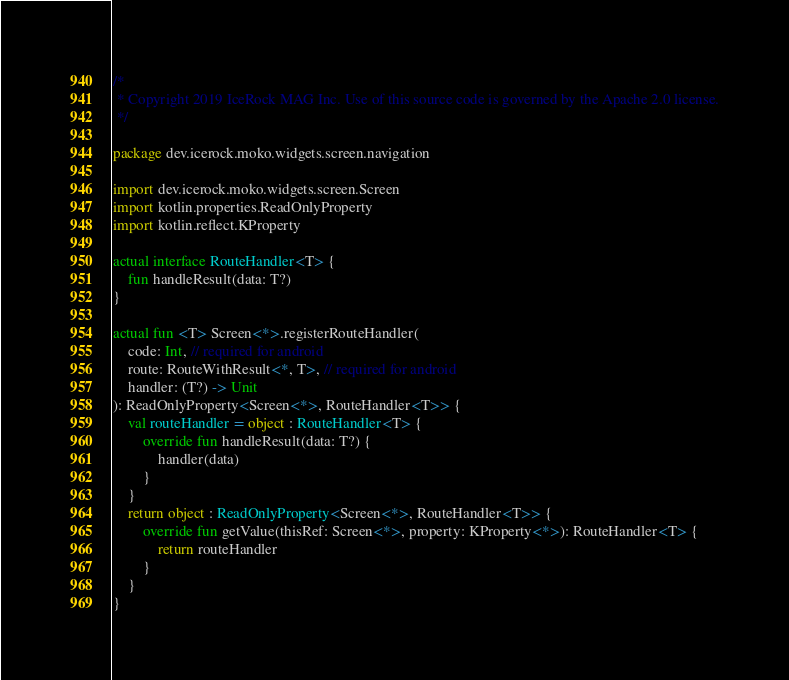<code> <loc_0><loc_0><loc_500><loc_500><_Kotlin_>/*
 * Copyright 2019 IceRock MAG Inc. Use of this source code is governed by the Apache 2.0 license.
 */

package dev.icerock.moko.widgets.screen.navigation

import dev.icerock.moko.widgets.screen.Screen
import kotlin.properties.ReadOnlyProperty
import kotlin.reflect.KProperty

actual interface RouteHandler<T> {
    fun handleResult(data: T?)
}

actual fun <T> Screen<*>.registerRouteHandler(
    code: Int, // required for android
    route: RouteWithResult<*, T>, // required for android
    handler: (T?) -> Unit
): ReadOnlyProperty<Screen<*>, RouteHandler<T>> {
    val routeHandler = object : RouteHandler<T> {
        override fun handleResult(data: T?) {
            handler(data)
        }
    }
    return object : ReadOnlyProperty<Screen<*>, RouteHandler<T>> {
        override fun getValue(thisRef: Screen<*>, property: KProperty<*>): RouteHandler<T> {
            return routeHandler
        }
    }
}
</code> 